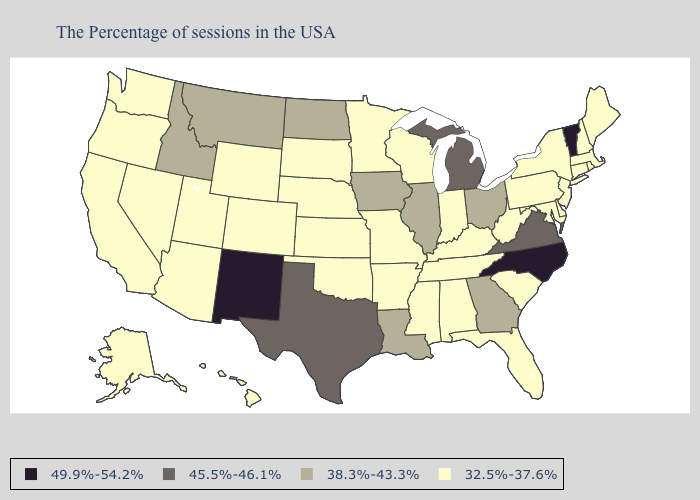Name the states that have a value in the range 32.5%-37.6%?
Give a very brief answer. Maine, Massachusetts, Rhode Island, New Hampshire, Connecticut, New York, New Jersey, Delaware, Maryland, Pennsylvania, South Carolina, West Virginia, Florida, Kentucky, Indiana, Alabama, Tennessee, Wisconsin, Mississippi, Missouri, Arkansas, Minnesota, Kansas, Nebraska, Oklahoma, South Dakota, Wyoming, Colorado, Utah, Arizona, Nevada, California, Washington, Oregon, Alaska, Hawaii. What is the lowest value in states that border Kentucky?
Short answer required. 32.5%-37.6%. Name the states that have a value in the range 38.3%-43.3%?
Give a very brief answer. Ohio, Georgia, Illinois, Louisiana, Iowa, North Dakota, Montana, Idaho. Does Colorado have the same value as Wisconsin?
Give a very brief answer. Yes. Which states have the highest value in the USA?
Keep it brief. Vermont, North Carolina, New Mexico. What is the value of Hawaii?
Concise answer only. 32.5%-37.6%. Does the first symbol in the legend represent the smallest category?
Be succinct. No. Name the states that have a value in the range 38.3%-43.3%?
Keep it brief. Ohio, Georgia, Illinois, Louisiana, Iowa, North Dakota, Montana, Idaho. Which states have the highest value in the USA?
Keep it brief. Vermont, North Carolina, New Mexico. What is the value of Missouri?
Give a very brief answer. 32.5%-37.6%. Does Tennessee have the lowest value in the South?
Concise answer only. Yes. Is the legend a continuous bar?
Quick response, please. No. Among the states that border North Dakota , does Minnesota have the lowest value?
Answer briefly. Yes. What is the highest value in states that border Georgia?
Answer briefly. 49.9%-54.2%. What is the value of Pennsylvania?
Give a very brief answer. 32.5%-37.6%. 